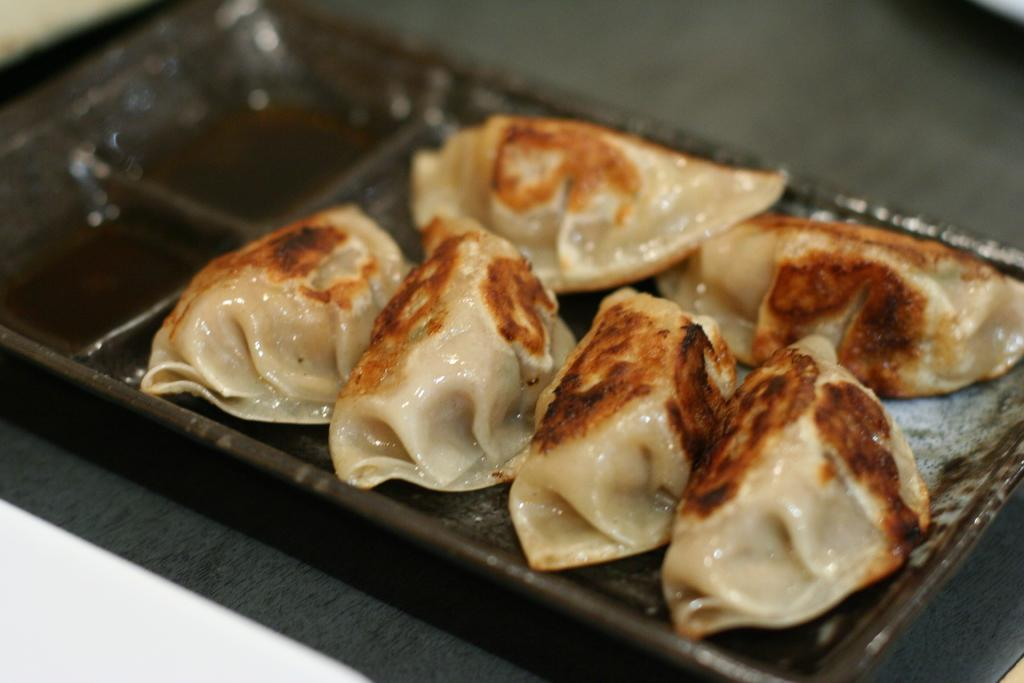What type of food can be seen in the image? The food in the image has cream and brown colors. How is the food arranged or presented? The food is in a tray. What is the color of the tray? The tray is brown in color. What type of fowl can be seen in the image? There is no fowl present in the image; it features food in a brown tray. How does the food help improve memory in the image? The image does not depict any food that is specifically related to memory improvement. 